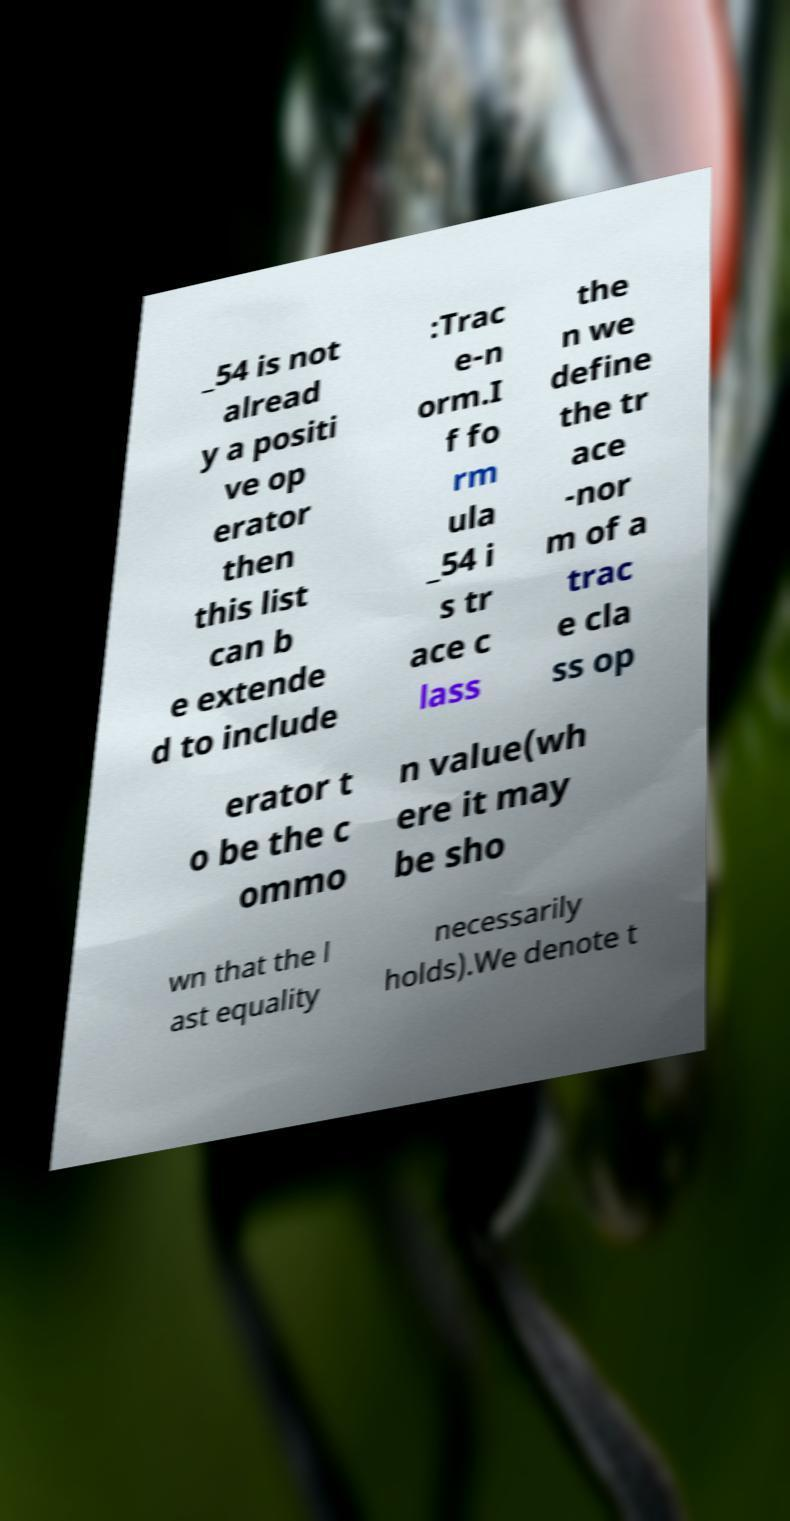Could you assist in decoding the text presented in this image and type it out clearly? _54 is not alread y a positi ve op erator then this list can b e extende d to include :Trac e-n orm.I f fo rm ula _54 i s tr ace c lass the n we define the tr ace -nor m of a trac e cla ss op erator t o be the c ommo n value(wh ere it may be sho wn that the l ast equality necessarily holds).We denote t 